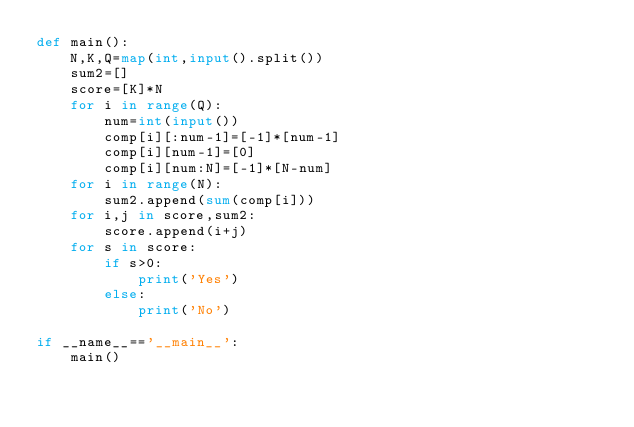<code> <loc_0><loc_0><loc_500><loc_500><_Python_>def main():
    N,K,Q=map(int,input().split())
    sum2=[]
    score=[K]*N
    for i in range(Q):
        num=int(input())
        comp[i][:num-1]=[-1]*[num-1]
        comp[i][num-1]=[0]
        comp[i][num:N]=[-1]*[N-num]
    for i in range(N):
        sum2.append(sum(comp[i]))
    for i,j in score,sum2:
        score.append(i+j)
    for s in score:
        if s>0:
            print('Yes')
        else:
            print('No')

if __name__=='__main__':
    main()
</code> 